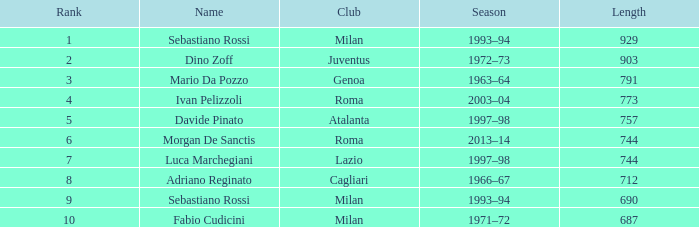What term is connected to an extended length beyond 903? Sebastiano Rossi. 